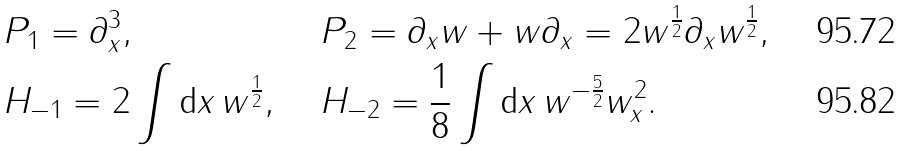<formula> <loc_0><loc_0><loc_500><loc_500>& P _ { 1 } = \partial _ { x } ^ { 3 } , & & P _ { 2 } = \partial _ { x } w + w \partial _ { x } = 2 w ^ { \frac { 1 } { 2 } } \partial _ { x } w ^ { \frac { 1 } { 2 } } , \\ & H _ { - 1 } = 2 \int { \tt d } x \, w ^ { \frac { 1 } { 2 } } , & & H _ { - 2 } = \frac { 1 } { 8 } \int { \tt d } x \, w ^ { - \frac { 5 } { 2 } } w _ { x } ^ { 2 } .</formula> 